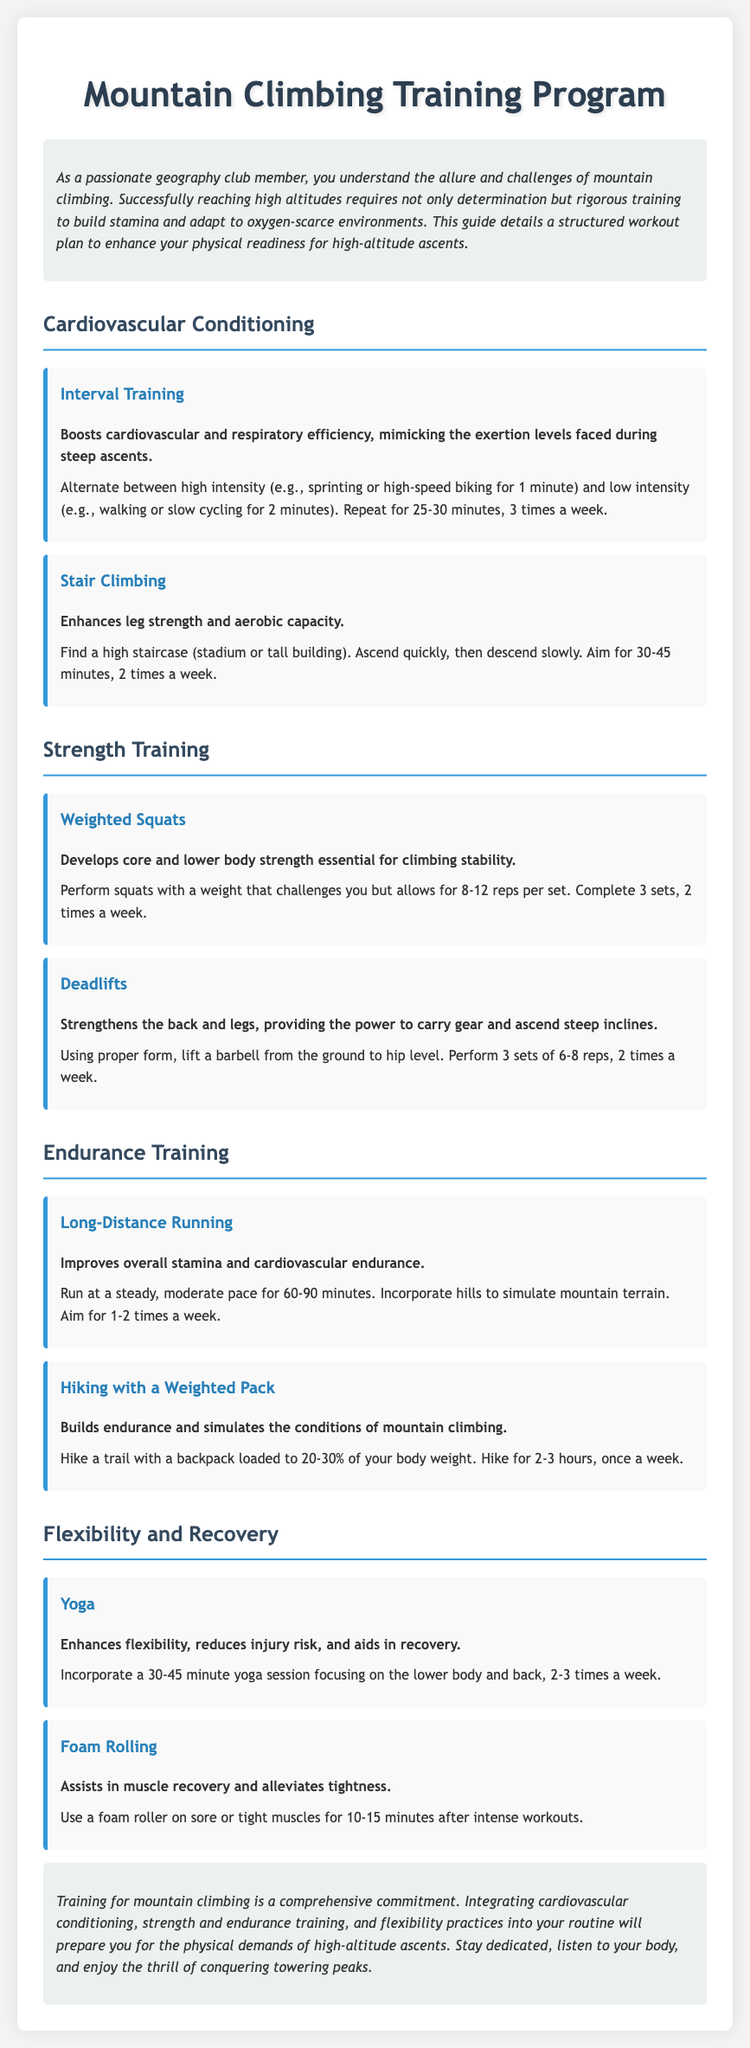what is the title of the document? The title is presented at the top of the rendered document.
Answer: Mountain Climbing Training Program how many times a week should you perform Interval Training? The frequency of Interval Training is specified in the workout details.
Answer: 3 times a week what exercise enhances leg strength and aerobic capacity? This information can be found in the strength training section of the document.
Answer: Stair Climbing how long should a Long-Distance Running session last? The duration for Long-Distance Running is mentioned within the workout description.
Answer: 60-90 minutes what exercise focuses on flexibility? The document indicates specific exercises aimed at increasing flexibility.
Answer: Yoga how much weight should the backpack be during Hiking with a Weighted Pack? This detail is provided in the description of the hiking activity.
Answer: 20-30% of your body weight how many sets are recommended for Weighted Squats? The number of sets for Weighted Squats is defined in the strength training section.
Answer: 3 sets what workout mimics the exertion levels faced during mountain climbing? This detail is included in the exercise description of the workout plan.
Answer: Interval Training how long should a foam rolling session last? The recommended duration for foam rolling is included in the recovery section.
Answer: 10-15 minutes 